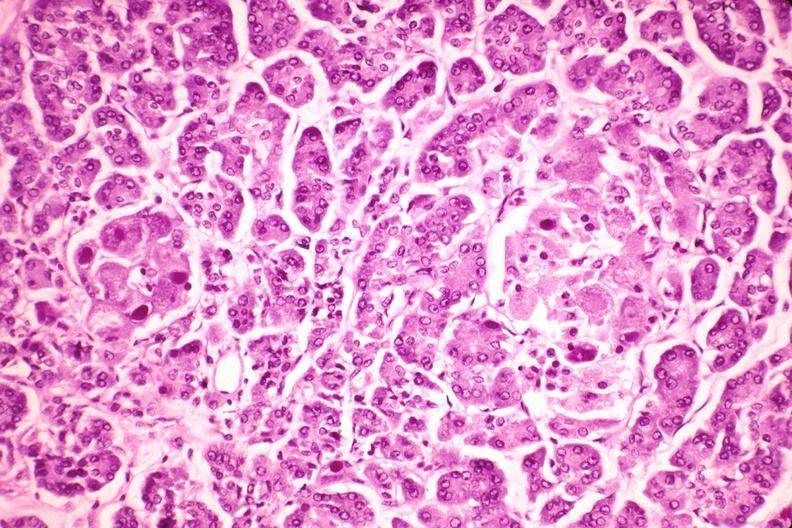does serous cystadenoma show pancreas, cytomegalovirus?
Answer the question using a single word or phrase. No 